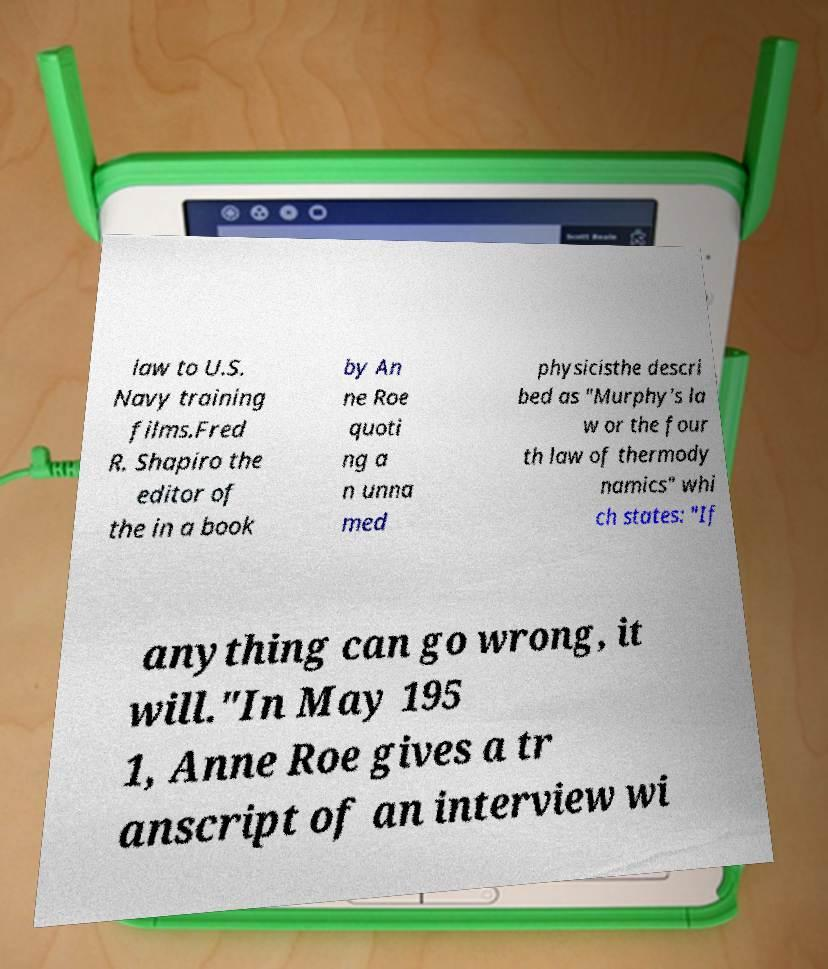Please identify and transcribe the text found in this image. law to U.S. Navy training films.Fred R. Shapiro the editor of the in a book by An ne Roe quoti ng a n unna med physicisthe descri bed as "Murphy's la w or the four th law of thermody namics" whi ch states: "If anything can go wrong, it will."In May 195 1, Anne Roe gives a tr anscript of an interview wi 